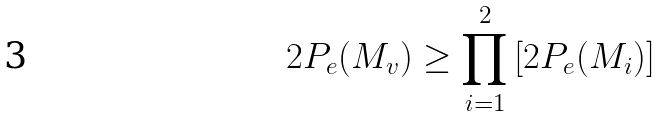<formula> <loc_0><loc_0><loc_500><loc_500>2 P _ { e } ( M _ { v } ) \geq \prod _ { i = 1 } ^ { 2 } \left [ 2 P _ { e } ( M _ { i } ) \right ]</formula> 